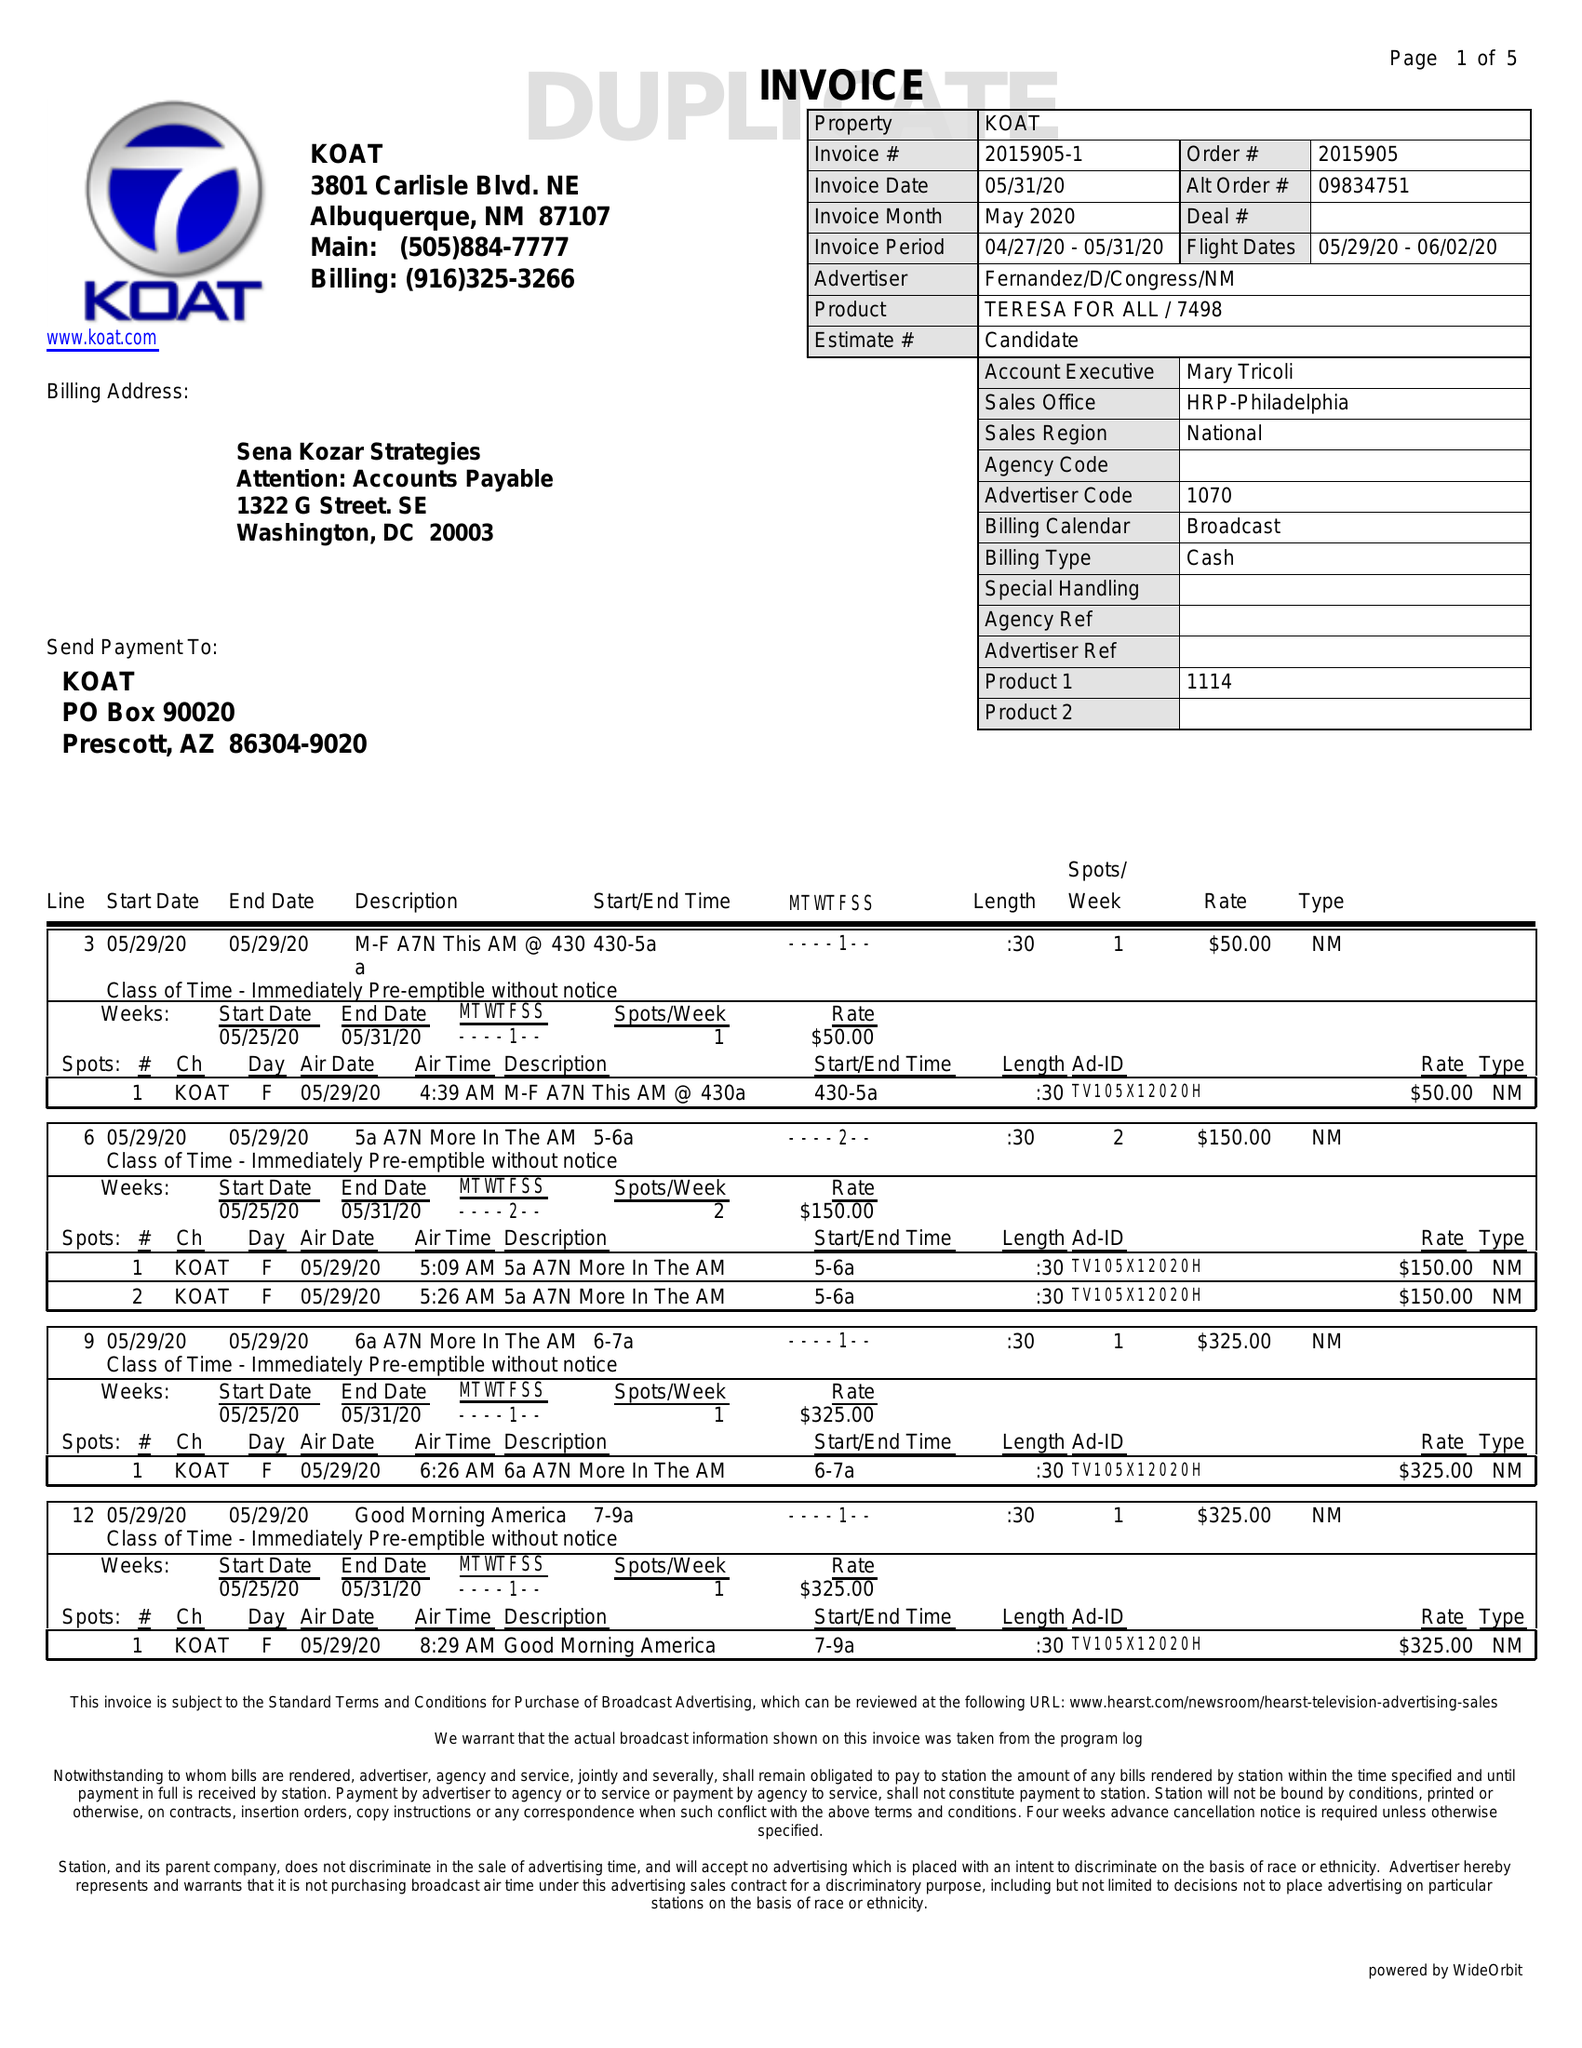What is the value for the advertiser?
Answer the question using a single word or phrase. FERNANDEZ/D/CONGRESS/NM 